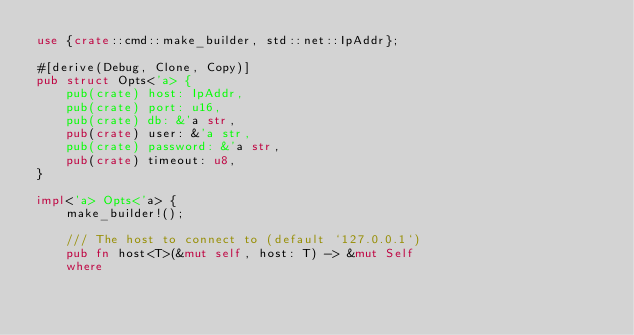<code> <loc_0><loc_0><loc_500><loc_500><_Rust_>use {crate::cmd::make_builder, std::net::IpAddr};

#[derive(Debug, Clone, Copy)]
pub struct Opts<'a> {
    pub(crate) host: IpAddr,
    pub(crate) port: u16,
    pub(crate) db: &'a str,
    pub(crate) user: &'a str,
    pub(crate) password: &'a str,
    pub(crate) timeout: u8,
}

impl<'a> Opts<'a> {
    make_builder!();

    /// The host to connect to (default `127.0.0.1`)
    pub fn host<T>(&mut self, host: T) -> &mut Self
    where</code> 